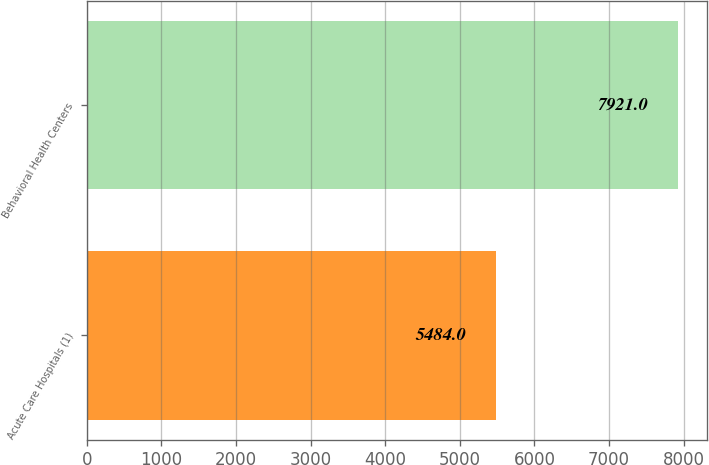Convert chart. <chart><loc_0><loc_0><loc_500><loc_500><bar_chart><fcel>Acute Care Hospitals (1)<fcel>Behavioral Health Centers<nl><fcel>5484<fcel>7921<nl></chart> 